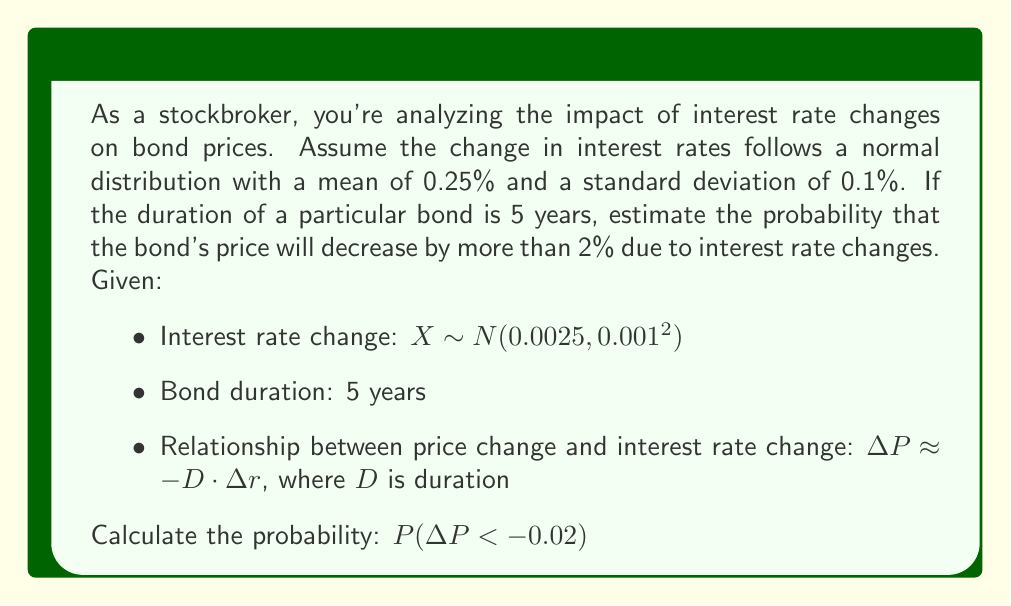Teach me how to tackle this problem. Let's approach this step-by-step:

1) First, we need to express the price change in terms of the interest rate change:
   $\Delta P \approx -D \cdot \Delta r$
   $\Delta P \approx -5 \cdot X$, where $X$ is the interest rate change

2) We want to find $P(\Delta P < -0.02)$, which is equivalent to:
   $P(-5X < -0.02)$
   $P(X > 0.004)$  (dividing both sides by -5 and flipping the inequality)

3) Now we need to standardize this probability:
   $Z = \frac{X - \mu}{\sigma}$, where $\mu = 0.0025$ and $\sigma = 0.001$

   $P(X > 0.004) = P(\frac{X - 0.0025}{0.001} > \frac{0.004 - 0.0025}{0.001})$
                 $= P(Z > 1.5)$

4) Using a standard normal distribution table or calculator:
   $P(Z > 1.5) \approx 0.0668$

Therefore, the probability that the bond's price will decrease by more than 2% is approximately 0.0668 or 6.68%.
Answer: 0.0668 (or 6.68%) 